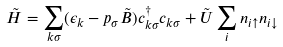<formula> <loc_0><loc_0><loc_500><loc_500>\tilde { H } = \sum _ { k \sigma } ( \epsilon _ { k } - p _ { \sigma } \tilde { B } ) c ^ { \dag } _ { k \sigma } c _ { k \sigma } + \tilde { U } \sum _ { i } n _ { i \uparrow } n _ { i \downarrow }</formula> 